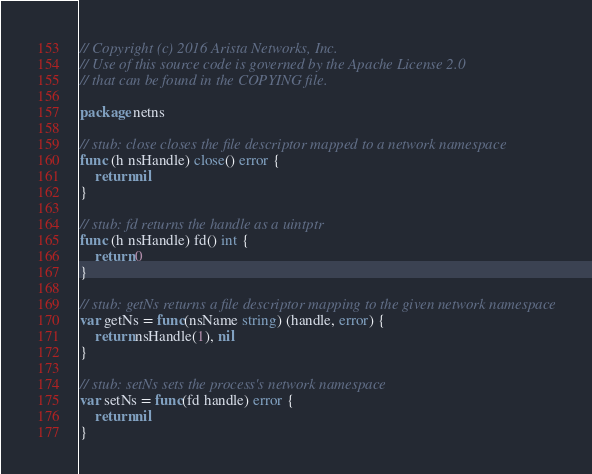<code> <loc_0><loc_0><loc_500><loc_500><_Go_>// Copyright (c) 2016 Arista Networks, Inc.
// Use of this source code is governed by the Apache License 2.0
// that can be found in the COPYING file.

package netns

// stub: close closes the file descriptor mapped to a network namespace
func (h nsHandle) close() error {
	return nil
}

// stub: fd returns the handle as a uintptr
func (h nsHandle) fd() int {
	return 0
}

// stub: getNs returns a file descriptor mapping to the given network namespace
var getNs = func(nsName string) (handle, error) {
	return nsHandle(1), nil
}

// stub: setNs sets the process's network namespace
var setNs = func(fd handle) error {
	return nil
}
</code> 